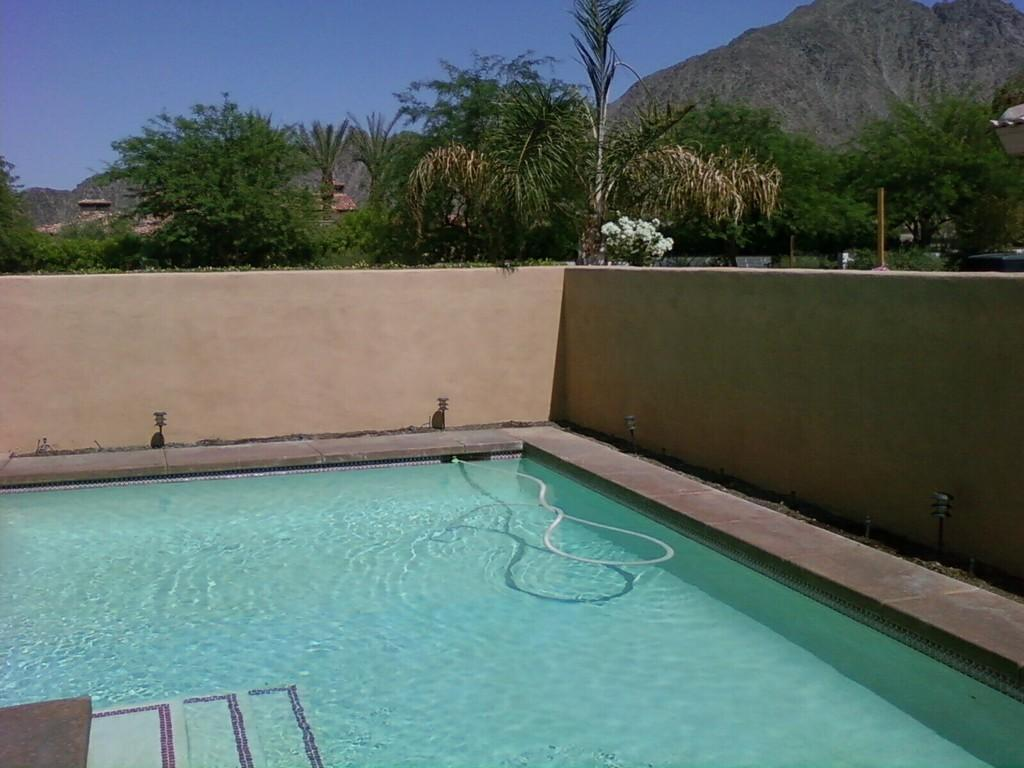What is the main feature of the image? There is a swimming pool in the image. What can be seen near the swimming pool? There are stairs, a pipe, and a walkway visible in the image. What structures are present in the background of the image? There is a wall, trees, poles, lights, hills, and the sky visible at the top of the image. How does the frame of the image express regret? The image does not have a frame, and there is no indication of regret in the image. 